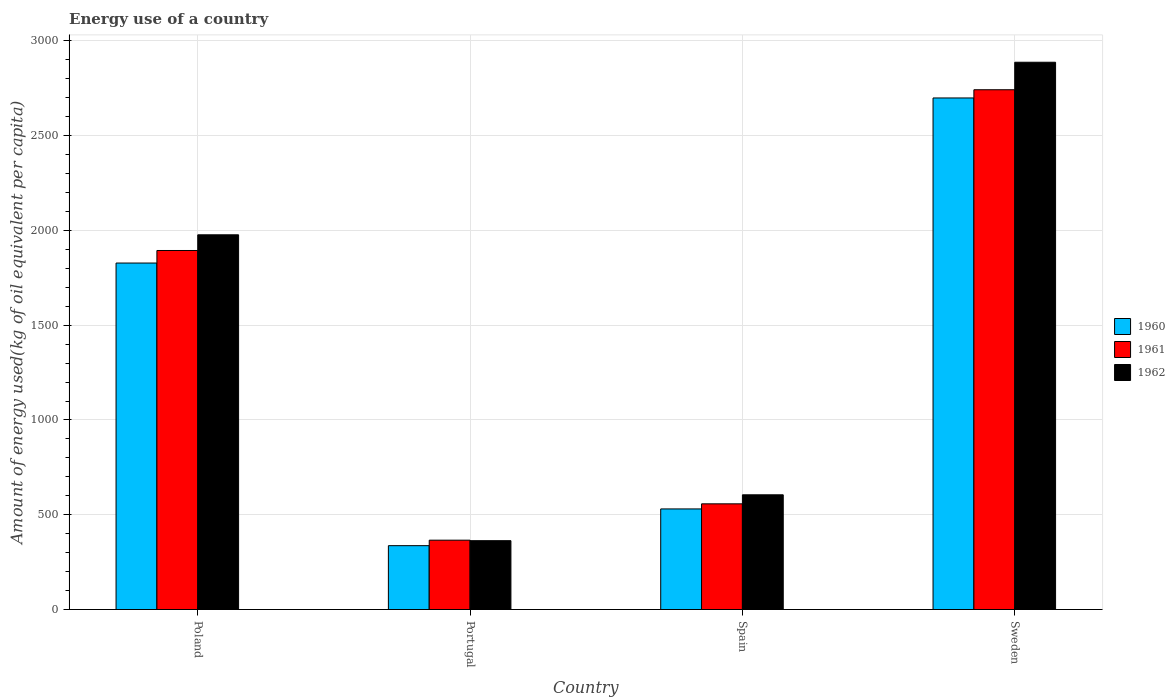How many groups of bars are there?
Your answer should be very brief. 4. Are the number of bars per tick equal to the number of legend labels?
Offer a terse response. Yes. How many bars are there on the 4th tick from the left?
Provide a short and direct response. 3. How many bars are there on the 4th tick from the right?
Keep it short and to the point. 3. What is the amount of energy used in in 1962 in Sweden?
Your response must be concise. 2887.24. Across all countries, what is the maximum amount of energy used in in 1960?
Keep it short and to the point. 2698.79. Across all countries, what is the minimum amount of energy used in in 1962?
Ensure brevity in your answer.  363.16. In which country was the amount of energy used in in 1961 minimum?
Ensure brevity in your answer.  Portugal. What is the total amount of energy used in in 1961 in the graph?
Provide a short and direct response. 5559.62. What is the difference between the amount of energy used in in 1960 in Portugal and that in Sweden?
Offer a terse response. -2361.88. What is the difference between the amount of energy used in in 1960 in Poland and the amount of energy used in in 1962 in Sweden?
Provide a short and direct response. -1059.3. What is the average amount of energy used in in 1960 per country?
Give a very brief answer. 1348.58. What is the difference between the amount of energy used in of/in 1962 and amount of energy used in of/in 1961 in Poland?
Make the answer very short. 82.8. In how many countries, is the amount of energy used in in 1961 greater than 500 kg?
Your response must be concise. 3. What is the ratio of the amount of energy used in in 1960 in Poland to that in Sweden?
Ensure brevity in your answer.  0.68. Is the amount of energy used in in 1961 in Poland less than that in Sweden?
Offer a very short reply. Yes. What is the difference between the highest and the second highest amount of energy used in in 1961?
Make the answer very short. 1336.46. What is the difference between the highest and the lowest amount of energy used in in 1962?
Your answer should be very brief. 2524.07. Are all the bars in the graph horizontal?
Provide a short and direct response. No. How many countries are there in the graph?
Give a very brief answer. 4. Does the graph contain any zero values?
Give a very brief answer. No. Does the graph contain grids?
Give a very brief answer. Yes. How many legend labels are there?
Offer a very short reply. 3. What is the title of the graph?
Provide a short and direct response. Energy use of a country. Does "1998" appear as one of the legend labels in the graph?
Make the answer very short. No. What is the label or title of the X-axis?
Provide a succinct answer. Country. What is the label or title of the Y-axis?
Provide a succinct answer. Amount of energy used(kg of oil equivalent per capita). What is the Amount of energy used(kg of oil equivalent per capita) in 1960 in Poland?
Give a very brief answer. 1827.94. What is the Amount of energy used(kg of oil equivalent per capita) of 1961 in Poland?
Provide a short and direct response. 1894.06. What is the Amount of energy used(kg of oil equivalent per capita) in 1962 in Poland?
Keep it short and to the point. 1976.86. What is the Amount of energy used(kg of oil equivalent per capita) in 1960 in Portugal?
Your response must be concise. 336.91. What is the Amount of energy used(kg of oil equivalent per capita) in 1961 in Portugal?
Keep it short and to the point. 365.84. What is the Amount of energy used(kg of oil equivalent per capita) of 1962 in Portugal?
Your answer should be compact. 363.16. What is the Amount of energy used(kg of oil equivalent per capita) of 1960 in Spain?
Your response must be concise. 530.66. What is the Amount of energy used(kg of oil equivalent per capita) of 1961 in Spain?
Offer a terse response. 557.6. What is the Amount of energy used(kg of oil equivalent per capita) in 1962 in Spain?
Offer a terse response. 605.22. What is the Amount of energy used(kg of oil equivalent per capita) in 1960 in Sweden?
Provide a succinct answer. 2698.79. What is the Amount of energy used(kg of oil equivalent per capita) of 1961 in Sweden?
Offer a very short reply. 2742.12. What is the Amount of energy used(kg of oil equivalent per capita) of 1962 in Sweden?
Provide a succinct answer. 2887.24. Across all countries, what is the maximum Amount of energy used(kg of oil equivalent per capita) in 1960?
Make the answer very short. 2698.79. Across all countries, what is the maximum Amount of energy used(kg of oil equivalent per capita) of 1961?
Provide a short and direct response. 2742.12. Across all countries, what is the maximum Amount of energy used(kg of oil equivalent per capita) in 1962?
Your answer should be compact. 2887.24. Across all countries, what is the minimum Amount of energy used(kg of oil equivalent per capita) in 1960?
Make the answer very short. 336.91. Across all countries, what is the minimum Amount of energy used(kg of oil equivalent per capita) in 1961?
Your answer should be compact. 365.84. Across all countries, what is the minimum Amount of energy used(kg of oil equivalent per capita) of 1962?
Your response must be concise. 363.16. What is the total Amount of energy used(kg of oil equivalent per capita) of 1960 in the graph?
Your answer should be very brief. 5394.31. What is the total Amount of energy used(kg of oil equivalent per capita) of 1961 in the graph?
Your response must be concise. 5559.62. What is the total Amount of energy used(kg of oil equivalent per capita) of 1962 in the graph?
Keep it short and to the point. 5832.48. What is the difference between the Amount of energy used(kg of oil equivalent per capita) of 1960 in Poland and that in Portugal?
Offer a terse response. 1491.02. What is the difference between the Amount of energy used(kg of oil equivalent per capita) in 1961 in Poland and that in Portugal?
Offer a very short reply. 1528.22. What is the difference between the Amount of energy used(kg of oil equivalent per capita) in 1962 in Poland and that in Portugal?
Your response must be concise. 1613.7. What is the difference between the Amount of energy used(kg of oil equivalent per capita) in 1960 in Poland and that in Spain?
Ensure brevity in your answer.  1297.27. What is the difference between the Amount of energy used(kg of oil equivalent per capita) of 1961 in Poland and that in Spain?
Keep it short and to the point. 1336.46. What is the difference between the Amount of energy used(kg of oil equivalent per capita) in 1962 in Poland and that in Spain?
Provide a short and direct response. 1371.64. What is the difference between the Amount of energy used(kg of oil equivalent per capita) in 1960 in Poland and that in Sweden?
Keep it short and to the point. -870.86. What is the difference between the Amount of energy used(kg of oil equivalent per capita) in 1961 in Poland and that in Sweden?
Keep it short and to the point. -848.07. What is the difference between the Amount of energy used(kg of oil equivalent per capita) of 1962 in Poland and that in Sweden?
Make the answer very short. -910.38. What is the difference between the Amount of energy used(kg of oil equivalent per capita) in 1960 in Portugal and that in Spain?
Provide a short and direct response. -193.75. What is the difference between the Amount of energy used(kg of oil equivalent per capita) in 1961 in Portugal and that in Spain?
Your answer should be very brief. -191.76. What is the difference between the Amount of energy used(kg of oil equivalent per capita) in 1962 in Portugal and that in Spain?
Provide a succinct answer. -242.06. What is the difference between the Amount of energy used(kg of oil equivalent per capita) of 1960 in Portugal and that in Sweden?
Keep it short and to the point. -2361.88. What is the difference between the Amount of energy used(kg of oil equivalent per capita) in 1961 in Portugal and that in Sweden?
Give a very brief answer. -2376.28. What is the difference between the Amount of energy used(kg of oil equivalent per capita) of 1962 in Portugal and that in Sweden?
Keep it short and to the point. -2524.07. What is the difference between the Amount of energy used(kg of oil equivalent per capita) in 1960 in Spain and that in Sweden?
Ensure brevity in your answer.  -2168.13. What is the difference between the Amount of energy used(kg of oil equivalent per capita) of 1961 in Spain and that in Sweden?
Make the answer very short. -2184.52. What is the difference between the Amount of energy used(kg of oil equivalent per capita) of 1962 in Spain and that in Sweden?
Your answer should be compact. -2282.01. What is the difference between the Amount of energy used(kg of oil equivalent per capita) of 1960 in Poland and the Amount of energy used(kg of oil equivalent per capita) of 1961 in Portugal?
Offer a terse response. 1462.1. What is the difference between the Amount of energy used(kg of oil equivalent per capita) of 1960 in Poland and the Amount of energy used(kg of oil equivalent per capita) of 1962 in Portugal?
Offer a very short reply. 1464.77. What is the difference between the Amount of energy used(kg of oil equivalent per capita) in 1961 in Poland and the Amount of energy used(kg of oil equivalent per capita) in 1962 in Portugal?
Make the answer very short. 1530.89. What is the difference between the Amount of energy used(kg of oil equivalent per capita) in 1960 in Poland and the Amount of energy used(kg of oil equivalent per capita) in 1961 in Spain?
Your answer should be compact. 1270.34. What is the difference between the Amount of energy used(kg of oil equivalent per capita) of 1960 in Poland and the Amount of energy used(kg of oil equivalent per capita) of 1962 in Spain?
Provide a succinct answer. 1222.71. What is the difference between the Amount of energy used(kg of oil equivalent per capita) in 1961 in Poland and the Amount of energy used(kg of oil equivalent per capita) in 1962 in Spain?
Keep it short and to the point. 1288.83. What is the difference between the Amount of energy used(kg of oil equivalent per capita) of 1960 in Poland and the Amount of energy used(kg of oil equivalent per capita) of 1961 in Sweden?
Give a very brief answer. -914.19. What is the difference between the Amount of energy used(kg of oil equivalent per capita) of 1960 in Poland and the Amount of energy used(kg of oil equivalent per capita) of 1962 in Sweden?
Your answer should be compact. -1059.3. What is the difference between the Amount of energy used(kg of oil equivalent per capita) of 1961 in Poland and the Amount of energy used(kg of oil equivalent per capita) of 1962 in Sweden?
Ensure brevity in your answer.  -993.18. What is the difference between the Amount of energy used(kg of oil equivalent per capita) in 1960 in Portugal and the Amount of energy used(kg of oil equivalent per capita) in 1961 in Spain?
Keep it short and to the point. -220.69. What is the difference between the Amount of energy used(kg of oil equivalent per capita) in 1960 in Portugal and the Amount of energy used(kg of oil equivalent per capita) in 1962 in Spain?
Offer a terse response. -268.31. What is the difference between the Amount of energy used(kg of oil equivalent per capita) in 1961 in Portugal and the Amount of energy used(kg of oil equivalent per capita) in 1962 in Spain?
Provide a succinct answer. -239.38. What is the difference between the Amount of energy used(kg of oil equivalent per capita) of 1960 in Portugal and the Amount of energy used(kg of oil equivalent per capita) of 1961 in Sweden?
Give a very brief answer. -2405.21. What is the difference between the Amount of energy used(kg of oil equivalent per capita) of 1960 in Portugal and the Amount of energy used(kg of oil equivalent per capita) of 1962 in Sweden?
Give a very brief answer. -2550.32. What is the difference between the Amount of energy used(kg of oil equivalent per capita) in 1961 in Portugal and the Amount of energy used(kg of oil equivalent per capita) in 1962 in Sweden?
Your response must be concise. -2521.4. What is the difference between the Amount of energy used(kg of oil equivalent per capita) of 1960 in Spain and the Amount of energy used(kg of oil equivalent per capita) of 1961 in Sweden?
Your answer should be very brief. -2211.46. What is the difference between the Amount of energy used(kg of oil equivalent per capita) of 1960 in Spain and the Amount of energy used(kg of oil equivalent per capita) of 1962 in Sweden?
Provide a succinct answer. -2356.57. What is the difference between the Amount of energy used(kg of oil equivalent per capita) of 1961 in Spain and the Amount of energy used(kg of oil equivalent per capita) of 1962 in Sweden?
Ensure brevity in your answer.  -2329.64. What is the average Amount of energy used(kg of oil equivalent per capita) of 1960 per country?
Ensure brevity in your answer.  1348.58. What is the average Amount of energy used(kg of oil equivalent per capita) in 1961 per country?
Offer a very short reply. 1389.91. What is the average Amount of energy used(kg of oil equivalent per capita) in 1962 per country?
Your response must be concise. 1458.12. What is the difference between the Amount of energy used(kg of oil equivalent per capita) of 1960 and Amount of energy used(kg of oil equivalent per capita) of 1961 in Poland?
Your answer should be very brief. -66.12. What is the difference between the Amount of energy used(kg of oil equivalent per capita) of 1960 and Amount of energy used(kg of oil equivalent per capita) of 1962 in Poland?
Your answer should be very brief. -148.92. What is the difference between the Amount of energy used(kg of oil equivalent per capita) of 1961 and Amount of energy used(kg of oil equivalent per capita) of 1962 in Poland?
Offer a terse response. -82.8. What is the difference between the Amount of energy used(kg of oil equivalent per capita) of 1960 and Amount of energy used(kg of oil equivalent per capita) of 1961 in Portugal?
Provide a succinct answer. -28.93. What is the difference between the Amount of energy used(kg of oil equivalent per capita) of 1960 and Amount of energy used(kg of oil equivalent per capita) of 1962 in Portugal?
Offer a terse response. -26.25. What is the difference between the Amount of energy used(kg of oil equivalent per capita) in 1961 and Amount of energy used(kg of oil equivalent per capita) in 1962 in Portugal?
Your answer should be compact. 2.68. What is the difference between the Amount of energy used(kg of oil equivalent per capita) of 1960 and Amount of energy used(kg of oil equivalent per capita) of 1961 in Spain?
Give a very brief answer. -26.93. What is the difference between the Amount of energy used(kg of oil equivalent per capita) of 1960 and Amount of energy used(kg of oil equivalent per capita) of 1962 in Spain?
Offer a terse response. -74.56. What is the difference between the Amount of energy used(kg of oil equivalent per capita) of 1961 and Amount of energy used(kg of oil equivalent per capita) of 1962 in Spain?
Ensure brevity in your answer.  -47.62. What is the difference between the Amount of energy used(kg of oil equivalent per capita) of 1960 and Amount of energy used(kg of oil equivalent per capita) of 1961 in Sweden?
Ensure brevity in your answer.  -43.33. What is the difference between the Amount of energy used(kg of oil equivalent per capita) of 1960 and Amount of energy used(kg of oil equivalent per capita) of 1962 in Sweden?
Your answer should be compact. -188.44. What is the difference between the Amount of energy used(kg of oil equivalent per capita) of 1961 and Amount of energy used(kg of oil equivalent per capita) of 1962 in Sweden?
Make the answer very short. -145.11. What is the ratio of the Amount of energy used(kg of oil equivalent per capita) in 1960 in Poland to that in Portugal?
Offer a terse response. 5.43. What is the ratio of the Amount of energy used(kg of oil equivalent per capita) of 1961 in Poland to that in Portugal?
Provide a short and direct response. 5.18. What is the ratio of the Amount of energy used(kg of oil equivalent per capita) in 1962 in Poland to that in Portugal?
Provide a short and direct response. 5.44. What is the ratio of the Amount of energy used(kg of oil equivalent per capita) in 1960 in Poland to that in Spain?
Offer a very short reply. 3.44. What is the ratio of the Amount of energy used(kg of oil equivalent per capita) of 1961 in Poland to that in Spain?
Provide a succinct answer. 3.4. What is the ratio of the Amount of energy used(kg of oil equivalent per capita) in 1962 in Poland to that in Spain?
Your answer should be very brief. 3.27. What is the ratio of the Amount of energy used(kg of oil equivalent per capita) of 1960 in Poland to that in Sweden?
Offer a very short reply. 0.68. What is the ratio of the Amount of energy used(kg of oil equivalent per capita) of 1961 in Poland to that in Sweden?
Your answer should be compact. 0.69. What is the ratio of the Amount of energy used(kg of oil equivalent per capita) in 1962 in Poland to that in Sweden?
Your answer should be compact. 0.68. What is the ratio of the Amount of energy used(kg of oil equivalent per capita) in 1960 in Portugal to that in Spain?
Offer a very short reply. 0.63. What is the ratio of the Amount of energy used(kg of oil equivalent per capita) in 1961 in Portugal to that in Spain?
Provide a short and direct response. 0.66. What is the ratio of the Amount of energy used(kg of oil equivalent per capita) in 1962 in Portugal to that in Spain?
Give a very brief answer. 0.6. What is the ratio of the Amount of energy used(kg of oil equivalent per capita) in 1960 in Portugal to that in Sweden?
Offer a very short reply. 0.12. What is the ratio of the Amount of energy used(kg of oil equivalent per capita) of 1961 in Portugal to that in Sweden?
Ensure brevity in your answer.  0.13. What is the ratio of the Amount of energy used(kg of oil equivalent per capita) in 1962 in Portugal to that in Sweden?
Make the answer very short. 0.13. What is the ratio of the Amount of energy used(kg of oil equivalent per capita) in 1960 in Spain to that in Sweden?
Your answer should be compact. 0.2. What is the ratio of the Amount of energy used(kg of oil equivalent per capita) of 1961 in Spain to that in Sweden?
Keep it short and to the point. 0.2. What is the ratio of the Amount of energy used(kg of oil equivalent per capita) of 1962 in Spain to that in Sweden?
Provide a short and direct response. 0.21. What is the difference between the highest and the second highest Amount of energy used(kg of oil equivalent per capita) in 1960?
Offer a terse response. 870.86. What is the difference between the highest and the second highest Amount of energy used(kg of oil equivalent per capita) of 1961?
Your answer should be compact. 848.07. What is the difference between the highest and the second highest Amount of energy used(kg of oil equivalent per capita) in 1962?
Provide a short and direct response. 910.38. What is the difference between the highest and the lowest Amount of energy used(kg of oil equivalent per capita) in 1960?
Ensure brevity in your answer.  2361.88. What is the difference between the highest and the lowest Amount of energy used(kg of oil equivalent per capita) in 1961?
Provide a succinct answer. 2376.28. What is the difference between the highest and the lowest Amount of energy used(kg of oil equivalent per capita) of 1962?
Provide a succinct answer. 2524.07. 